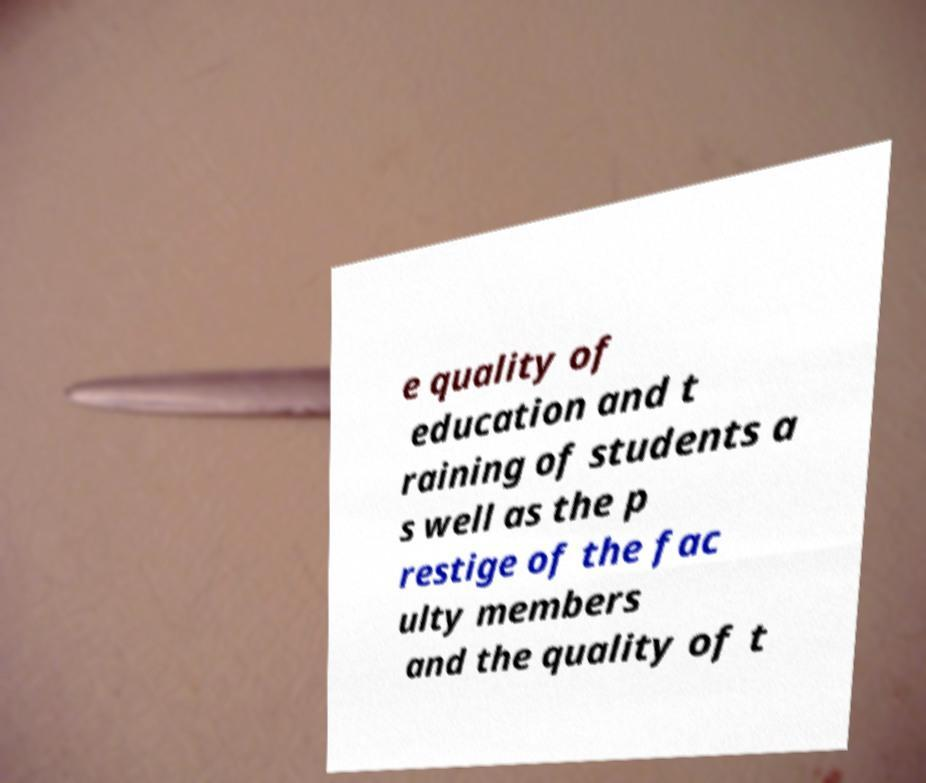What messages or text are displayed in this image? I need them in a readable, typed format. e quality of education and t raining of students a s well as the p restige of the fac ulty members and the quality of t 